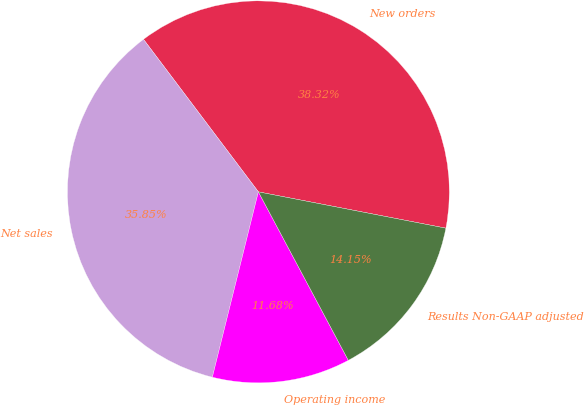Convert chart to OTSL. <chart><loc_0><loc_0><loc_500><loc_500><pie_chart><fcel>New orders<fcel>Net sales<fcel>Operating income<fcel>Results Non-GAAP adjusted<nl><fcel>38.32%<fcel>35.85%<fcel>11.68%<fcel>14.15%<nl></chart> 